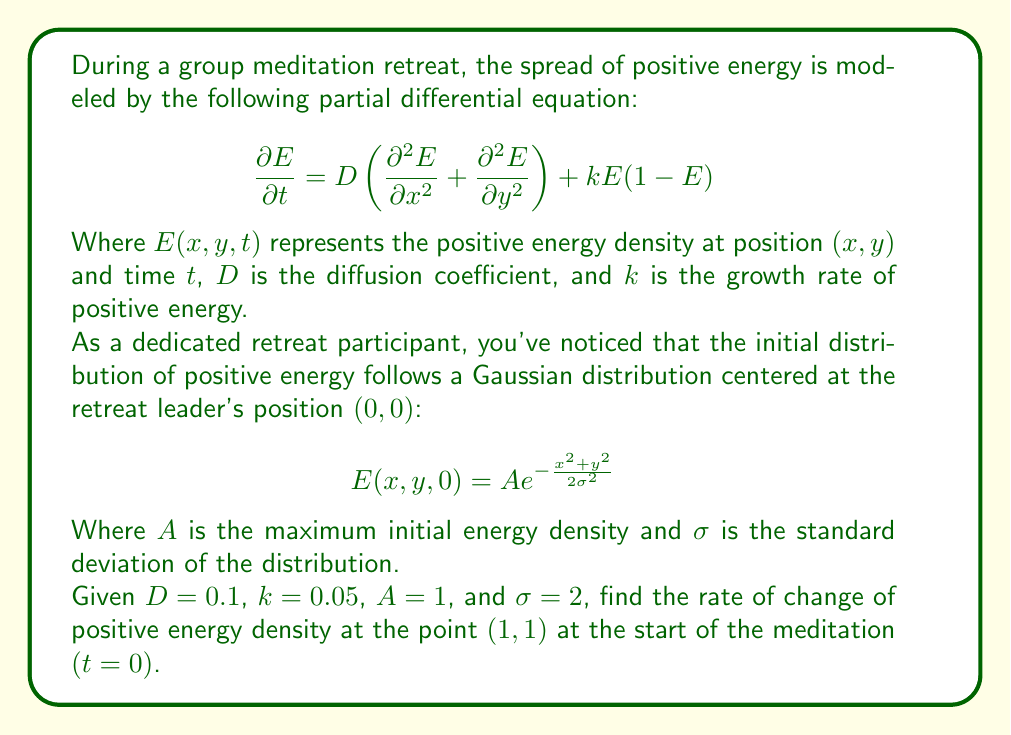Provide a solution to this math problem. To solve this problem, we need to follow these steps:

1) The rate of change of positive energy density is given by the left-hand side of the PDE: $\frac{\partial E}{\partial t}$

2) At $t=0$, we need to evaluate the right-hand side of the PDE:

   $$D\left(\frac{\partial^2 E}{\partial x^2} + \frac{\partial^2 E}{\partial y^2}\right) + kE(1-E)$$

3) First, let's calculate $E(1,1,0)$ using the initial distribution:

   $$E(1,1,0) = A e^{-\frac{1^2+1^2}{2\sigma^2}} = 1 \cdot e^{-\frac{2}{2\cdot2^2}} = e^{-\frac{1}{4}} \approx 0.7788$$

4) Now, we need to calculate $\frac{\partial^2 E}{\partial x^2}$ and $\frac{\partial^2 E}{\partial y^2}$ at $(1,1,0)$:

   $$\frac{\partial E}{\partial x} = A \cdot (-\frac{x}{\sigma^2}) \cdot e^{-\frac{x^2+y^2}{2\sigma^2}}$$
   
   $$\frac{\partial^2 E}{\partial x^2} = A \cdot \left(\frac{x^2}{\sigma^4} - \frac{1}{\sigma^2}\right) \cdot e^{-\frac{x^2+y^2}{2\sigma^2}}$$

   At $(1,1,0)$: $\frac{\partial^2 E}{\partial x^2} = \left(\frac{1}{16} - \frac{1}{4}\right) \cdot e^{-\frac{1}{4}} \approx -0.1460$

   Due to symmetry, $\frac{\partial^2 E}{\partial y^2}$ at $(1,1,0)$ is the same: $-0.1460$

5) Now we can evaluate the right-hand side of the PDE:

   $$0.1(-0.1460 - 0.1460) + 0.05 \cdot 0.7788 \cdot (1-0.7788)$$
   
   $$= -0.0292 + 0.0086 = -0.0206$$

Therefore, the rate of change of positive energy density at $(1,1)$ at $t=0$ is $-0.0206$.
Answer: $\frac{\partial E}{\partial t}(1,1,0) = -0.0206$ 